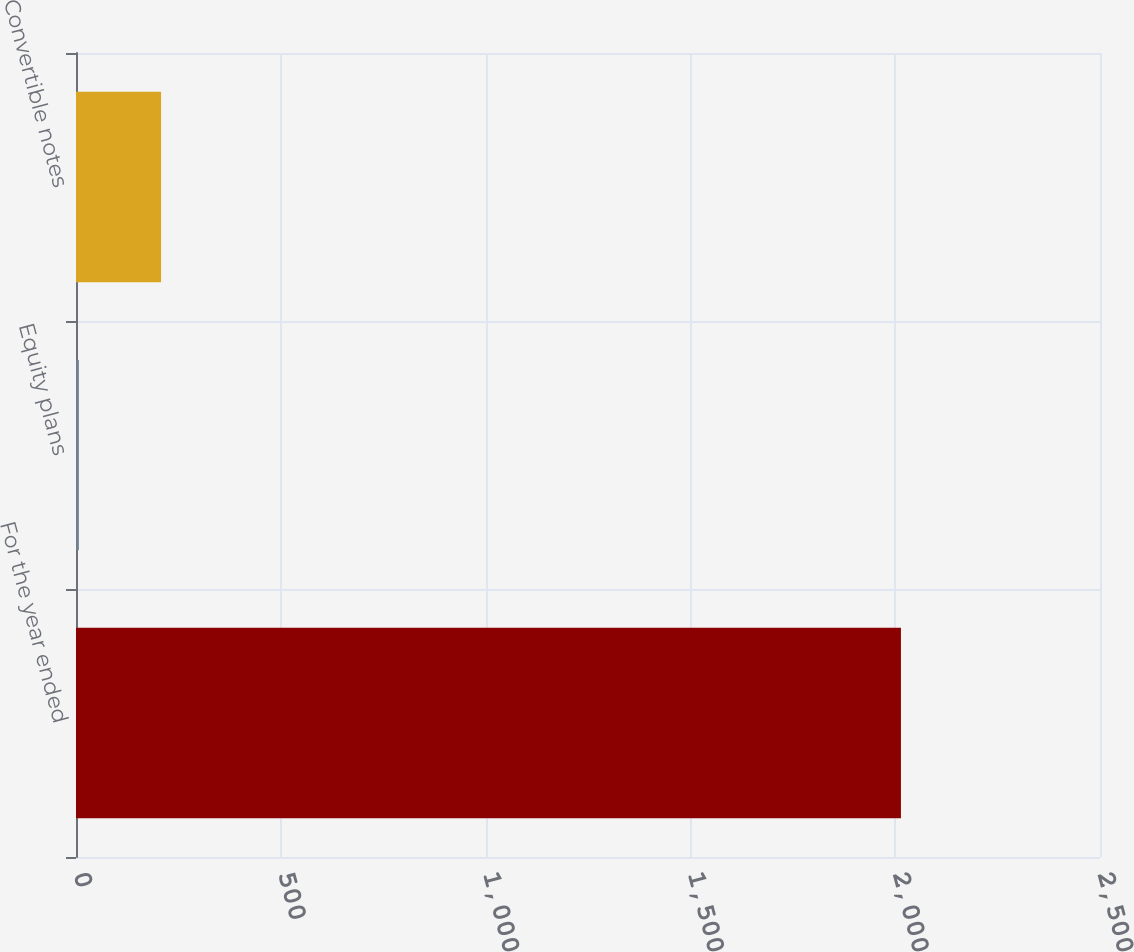Convert chart. <chart><loc_0><loc_0><loc_500><loc_500><bar_chart><fcel>For the year ended<fcel>Equity plans<fcel>Convertible notes<nl><fcel>2014<fcel>7<fcel>207.7<nl></chart> 